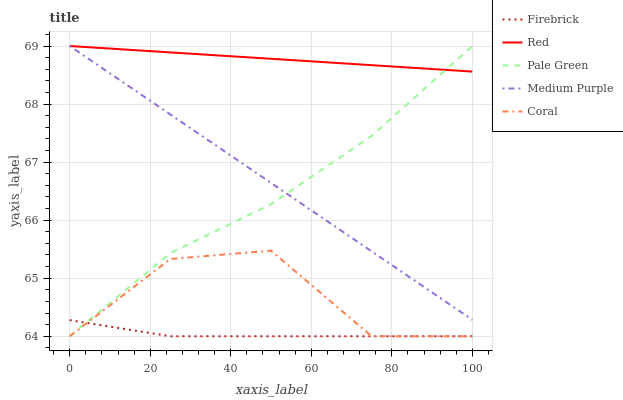Does Firebrick have the minimum area under the curve?
Answer yes or no. Yes. Does Red have the maximum area under the curve?
Answer yes or no. Yes. Does Pale Green have the minimum area under the curve?
Answer yes or no. No. Does Pale Green have the maximum area under the curve?
Answer yes or no. No. Is Red the smoothest?
Answer yes or no. Yes. Is Coral the roughest?
Answer yes or no. Yes. Is Firebrick the smoothest?
Answer yes or no. No. Is Firebrick the roughest?
Answer yes or no. No. Does Red have the lowest value?
Answer yes or no. No. Does Red have the highest value?
Answer yes or no. Yes. Does Firebrick have the highest value?
Answer yes or no. No. Is Firebrick less than Red?
Answer yes or no. Yes. Is Red greater than Coral?
Answer yes or no. Yes. Does Coral intersect Pale Green?
Answer yes or no. Yes. Is Coral less than Pale Green?
Answer yes or no. No. Is Coral greater than Pale Green?
Answer yes or no. No. Does Firebrick intersect Red?
Answer yes or no. No. 